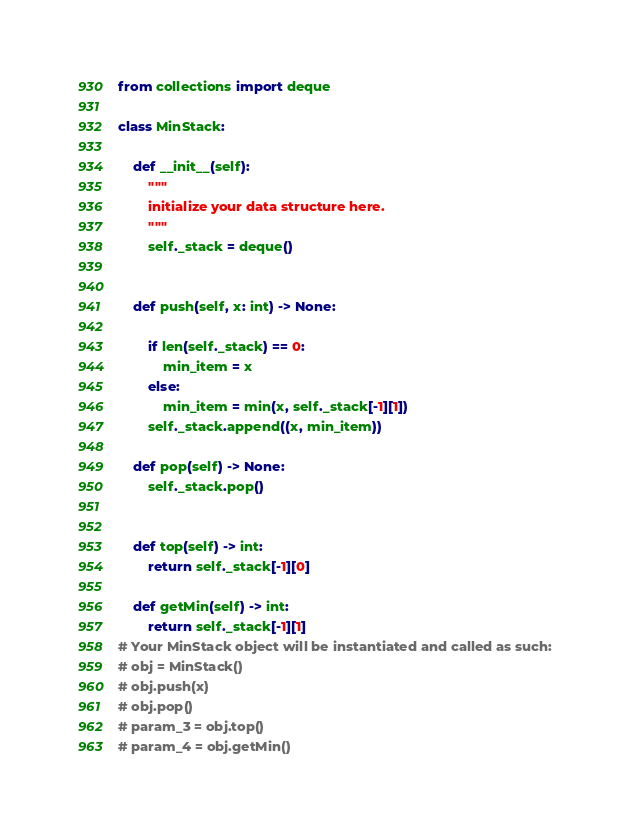<code> <loc_0><loc_0><loc_500><loc_500><_Python_>from collections import deque

class MinStack:

    def __init__(self):
        """
        initialize your data structure here.
        """
        self._stack = deque()
        

    def push(self, x: int) -> None:
	   
        if len(self._stack) == 0:
            min_item = x
        else:
            min_item = min(x, self._stack[-1][1])
        self._stack.append((x, min_item))

    def pop(self) -> None:
        self._stack.pop()
        

    def top(self) -> int:
        return self._stack[-1][0]

    def getMin(self) -> int:
        return self._stack[-1][1]
# Your MinStack object will be instantiated and called as such:
# obj = MinStack()
# obj.push(x)
# obj.pop()
# param_3 = obj.top()
# param_4 = obj.getMin()</code> 